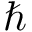<formula> <loc_0><loc_0><loc_500><loc_500>\hbar</formula> 